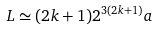<formula> <loc_0><loc_0><loc_500><loc_500>L \simeq ( 2 k + 1 ) 2 ^ { 3 ( 2 k + 1 ) } a</formula> 